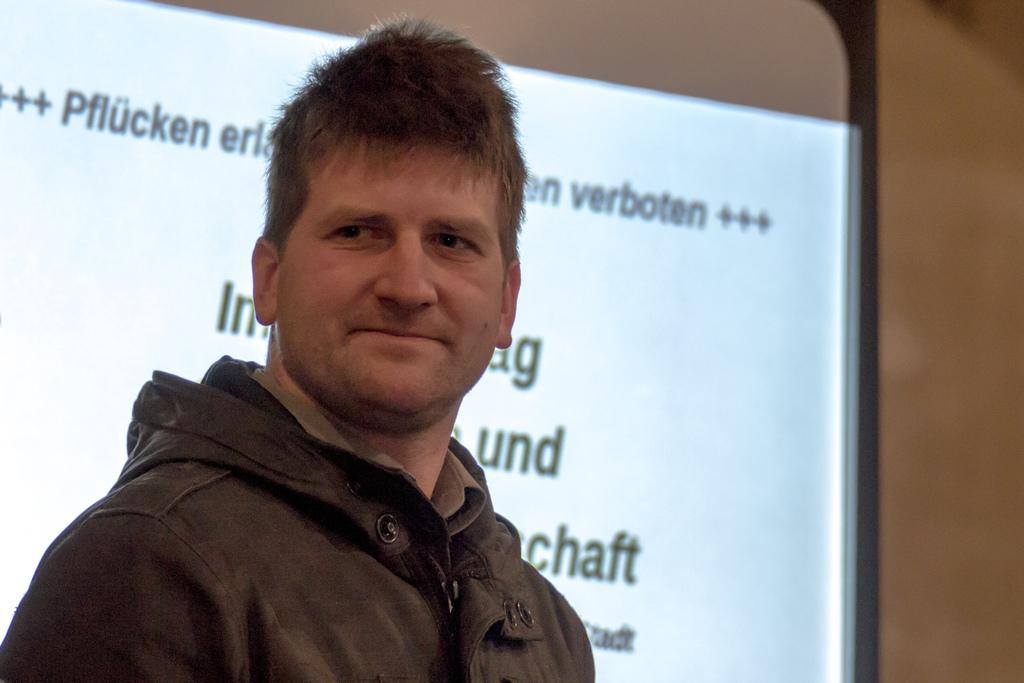What is the man in the image doing? The man is standing in the image and smiling. What is located behind the man in the image? There is a projector board behind the man. What can be seen on the projector board? There is text displayed on the projector board. Are there any giants visible in the image? No, there are no giants present in the image. What type of magic is being performed by the man in the image? There is no magic or any indication of a magical performance in the image. 